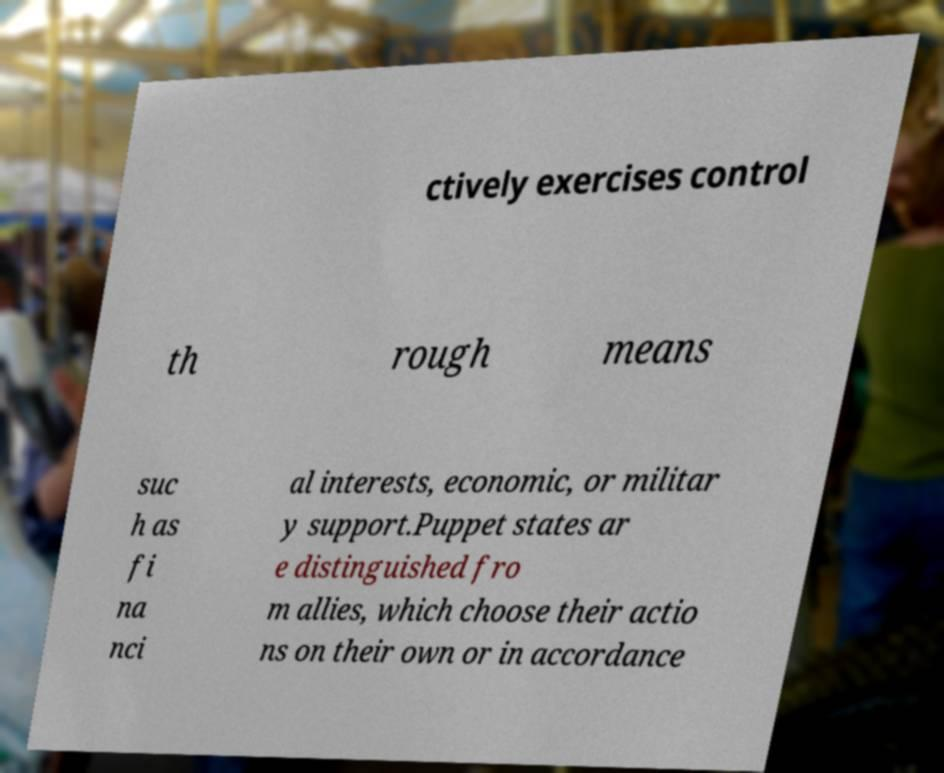For documentation purposes, I need the text within this image transcribed. Could you provide that? ctively exercises control th rough means suc h as fi na nci al interests, economic, or militar y support.Puppet states ar e distinguished fro m allies, which choose their actio ns on their own or in accordance 